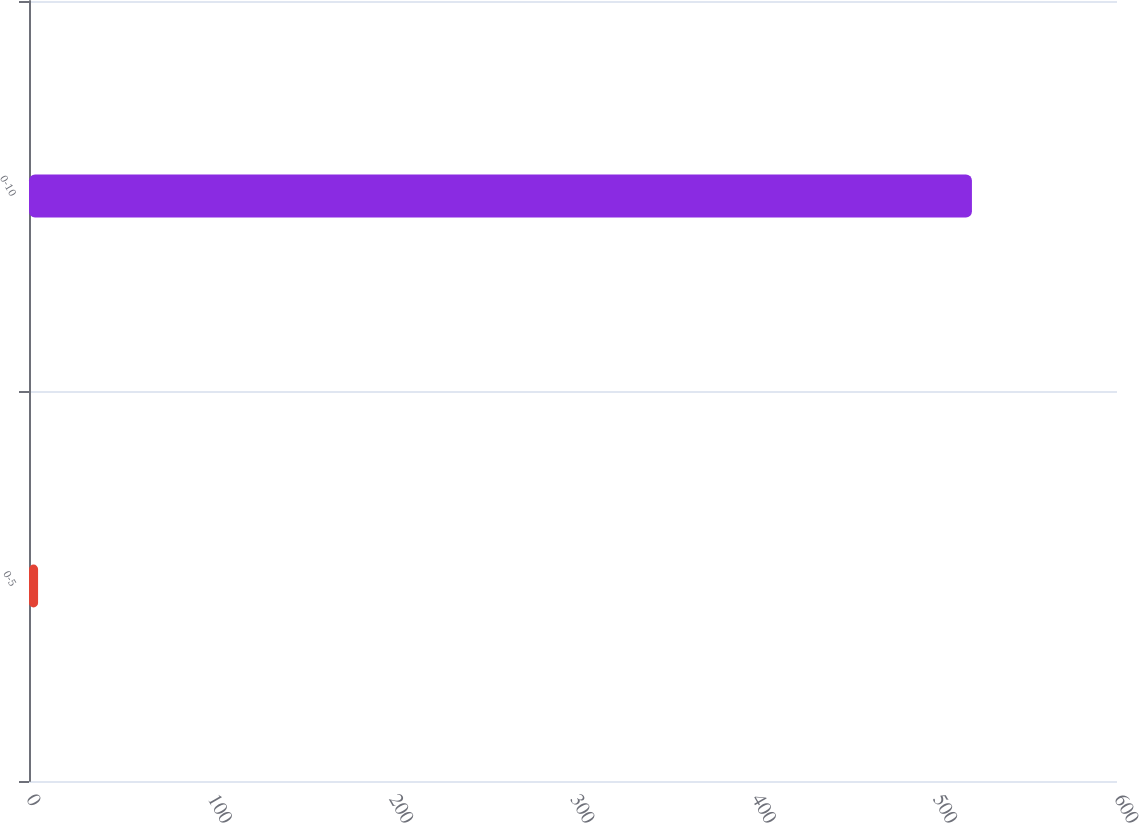Convert chart. <chart><loc_0><loc_0><loc_500><loc_500><bar_chart><fcel>0-5<fcel>0-10<nl><fcel>5<fcel>520<nl></chart> 